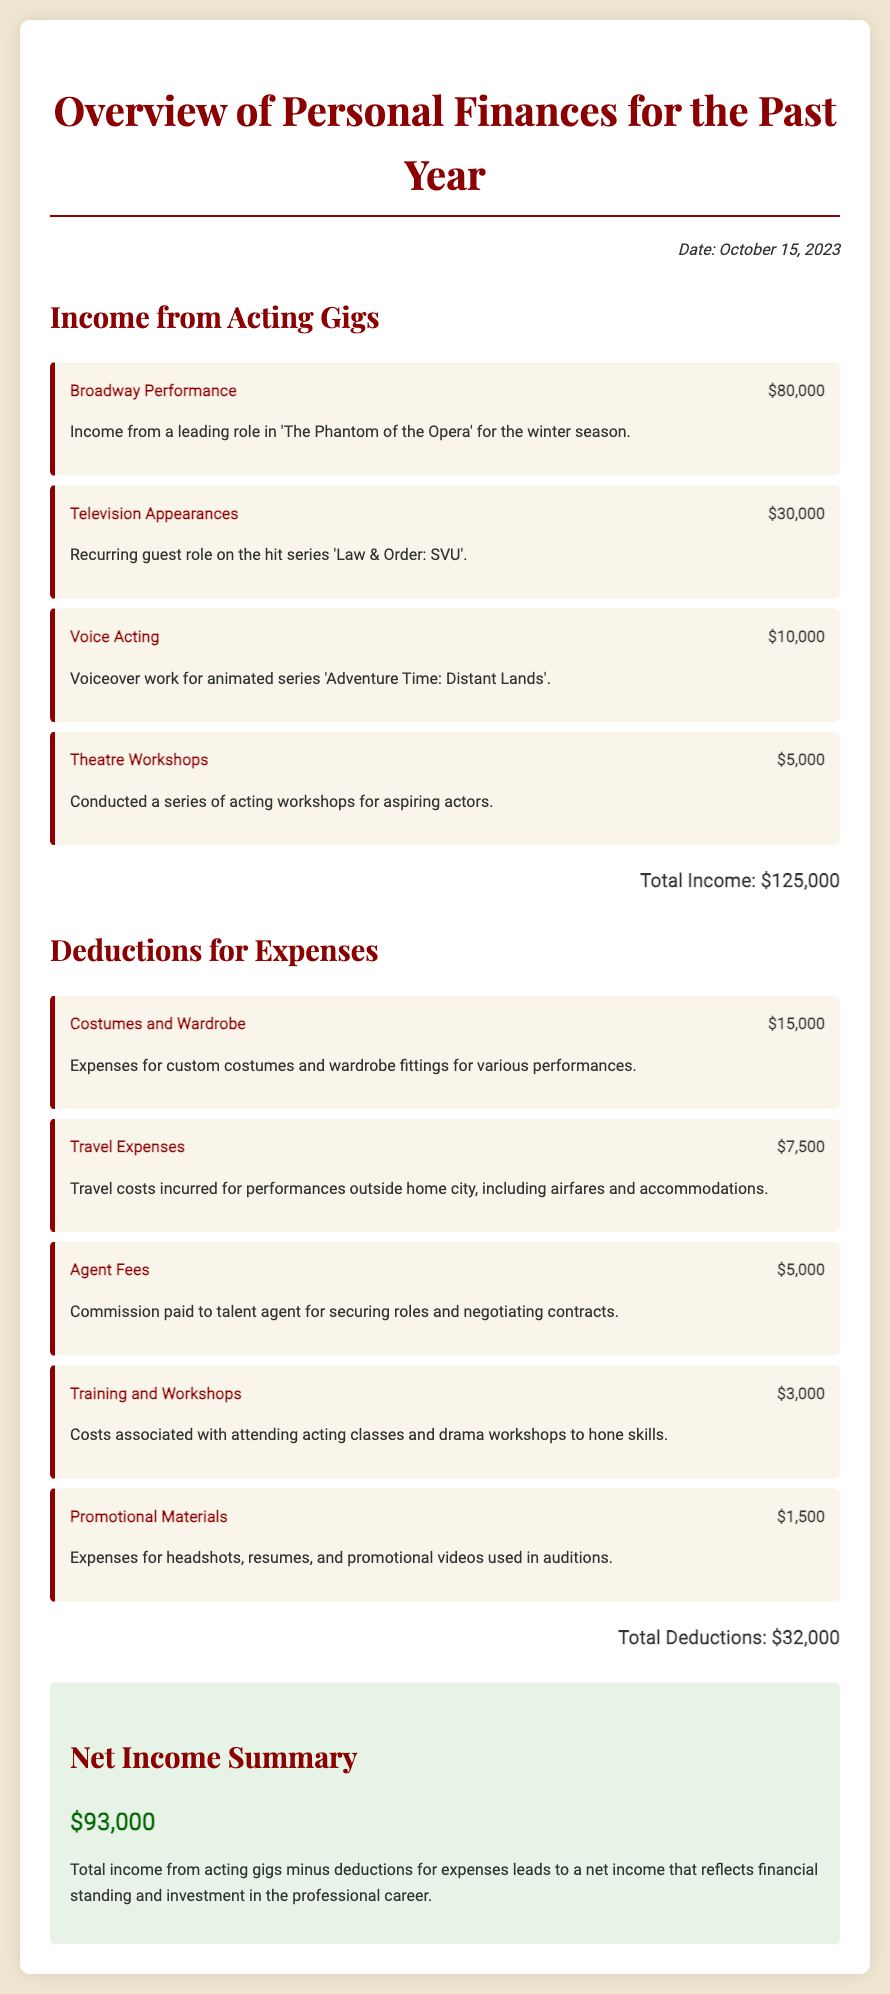What is the date of the financial overview? The date of the financial overview is mentioned at the top of the document as October 15, 2023.
Answer: October 15, 2023 What is the total income reported? The total income is calculated by summing all income sources listed in the document, which equals $80,000 + $30,000 + $10,000 + $5,000.
Answer: $125,000 What is the expense for costumes and wardrobe? The document lists the expense specifically under deductions, stating that it amounts to $15,000.
Answer: $15,000 What is the total deductions for expenses? The total deductions are calculated based on the listed expenses, which sum up to $32,000 in total.
Answer: $32,000 What is the net income calculated in the document? The net income is derived from total income minus total deductions, equating to $125,000 - $32,000.
Answer: $93,000 Which income source has the highest contribution? The document indicates that the highest income source is from Broadway Performance, which contributes $80,000.
Answer: Broadway Performance What is the category with the least amount of deduction? The deductions category with the least amount is Promotional Materials, which has expenses of $1,500.
Answer: Promotional Materials How many income sources are listed? The document mentions four distinct income sources under the income section.
Answer: Four What types of expenses are listed in the deductions? The document categorizes various expense types, including Costumes and Wardrobe, Travel Expenses, Agent Fees, Training and Workshops, and Promotional Materials.
Answer: Five 